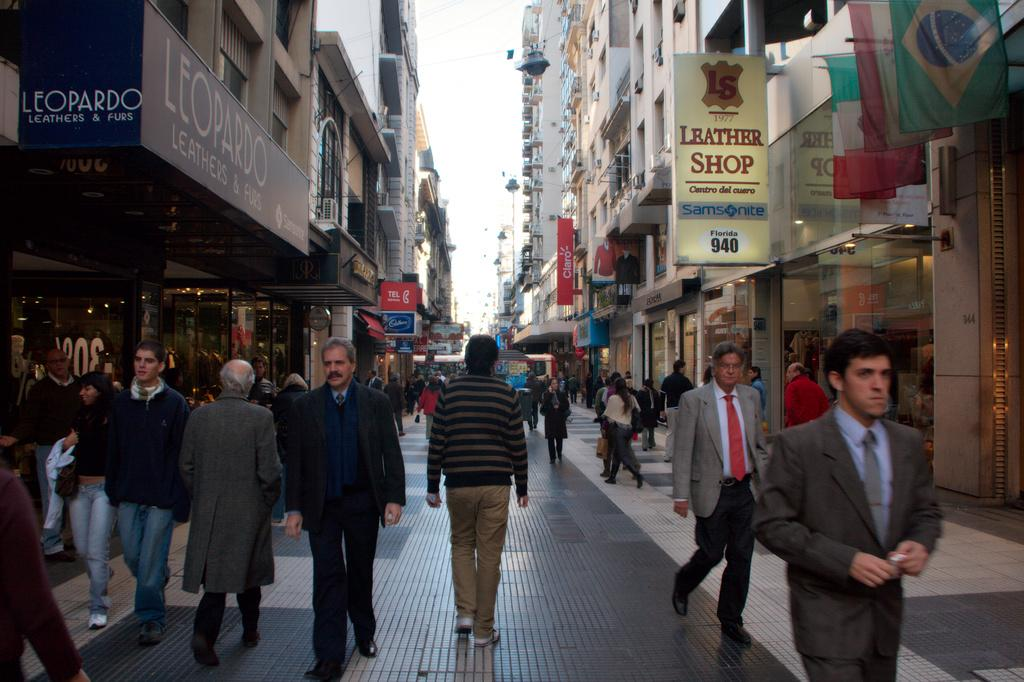What are the people in the image doing? The people in the image are walking on the street. What can be seen on both sides of the street? There are buildings on both sides of the street. What decorations are present on the buildings? Posters, banners, and flags are visible on the buildings. What is visible at the top of the image? The sky is visible at the top of the image. What type of twig is being used as a walking aid by the people in the image? There are no twigs present in the image; the people are walking without any walking aids. How many feet are visible in the image? The number of feet visible in the image cannot be determined from the provided facts, as the focus is on the people walking and the buildings. 